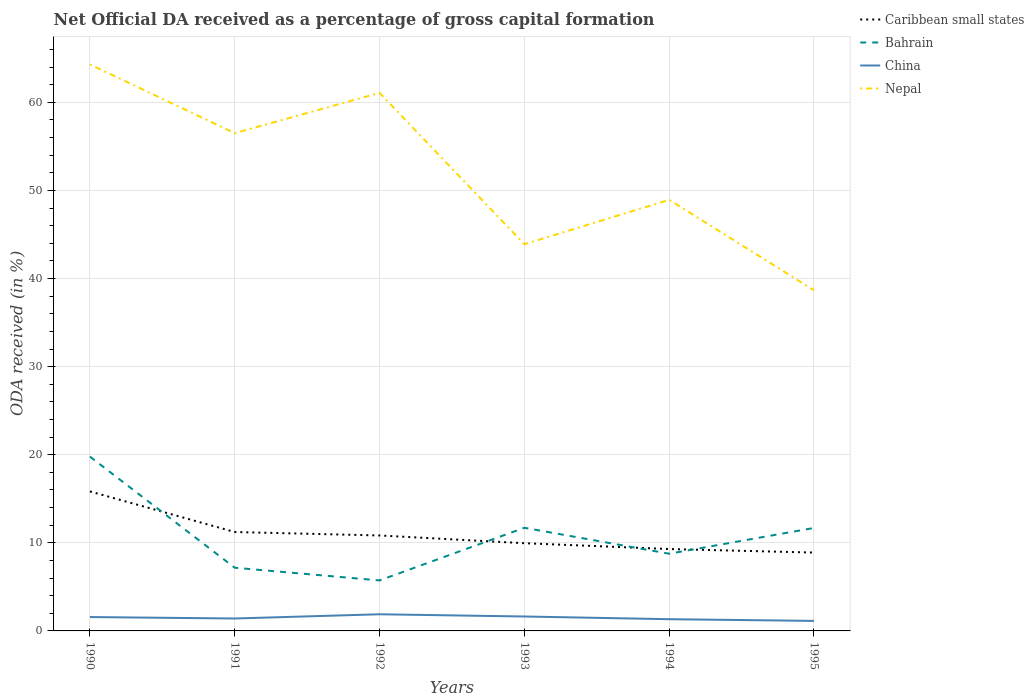How many different coloured lines are there?
Make the answer very short. 4. Is the number of lines equal to the number of legend labels?
Provide a short and direct response. Yes. Across all years, what is the maximum net ODA received in China?
Ensure brevity in your answer.  1.14. In which year was the net ODA received in Nepal maximum?
Provide a short and direct response. 1995. What is the total net ODA received in Bahrain in the graph?
Your response must be concise. 1.44. What is the difference between the highest and the second highest net ODA received in Nepal?
Your response must be concise. 25.64. What is the difference between the highest and the lowest net ODA received in China?
Keep it short and to the point. 3. How many years are there in the graph?
Give a very brief answer. 6. Are the values on the major ticks of Y-axis written in scientific E-notation?
Your response must be concise. No. Does the graph contain any zero values?
Your response must be concise. No. Does the graph contain grids?
Keep it short and to the point. Yes. Where does the legend appear in the graph?
Keep it short and to the point. Top right. What is the title of the graph?
Offer a very short reply. Net Official DA received as a percentage of gross capital formation. Does "Lithuania" appear as one of the legend labels in the graph?
Provide a succinct answer. No. What is the label or title of the Y-axis?
Offer a terse response. ODA received (in %). What is the ODA received (in %) in Caribbean small states in 1990?
Your response must be concise. 15.84. What is the ODA received (in %) in Bahrain in 1990?
Provide a short and direct response. 19.79. What is the ODA received (in %) in China in 1990?
Keep it short and to the point. 1.58. What is the ODA received (in %) in Nepal in 1990?
Give a very brief answer. 64.31. What is the ODA received (in %) in Caribbean small states in 1991?
Your response must be concise. 11.23. What is the ODA received (in %) in Bahrain in 1991?
Ensure brevity in your answer.  7.17. What is the ODA received (in %) of China in 1991?
Ensure brevity in your answer.  1.41. What is the ODA received (in %) in Nepal in 1991?
Give a very brief answer. 56.5. What is the ODA received (in %) in Caribbean small states in 1992?
Ensure brevity in your answer.  10.84. What is the ODA received (in %) in Bahrain in 1992?
Ensure brevity in your answer.  5.73. What is the ODA received (in %) in China in 1992?
Provide a succinct answer. 1.89. What is the ODA received (in %) in Nepal in 1992?
Keep it short and to the point. 61.08. What is the ODA received (in %) of Caribbean small states in 1993?
Your answer should be very brief. 9.96. What is the ODA received (in %) in Bahrain in 1993?
Ensure brevity in your answer.  11.71. What is the ODA received (in %) in China in 1993?
Provide a short and direct response. 1.64. What is the ODA received (in %) in Nepal in 1993?
Ensure brevity in your answer.  43.9. What is the ODA received (in %) of Caribbean small states in 1994?
Provide a succinct answer. 9.3. What is the ODA received (in %) in Bahrain in 1994?
Your answer should be very brief. 8.76. What is the ODA received (in %) in China in 1994?
Make the answer very short. 1.33. What is the ODA received (in %) of Nepal in 1994?
Keep it short and to the point. 48.94. What is the ODA received (in %) of Caribbean small states in 1995?
Give a very brief answer. 8.89. What is the ODA received (in %) in Bahrain in 1995?
Provide a succinct answer. 11.69. What is the ODA received (in %) of China in 1995?
Make the answer very short. 1.14. What is the ODA received (in %) in Nepal in 1995?
Your answer should be compact. 38.66. Across all years, what is the maximum ODA received (in %) in Caribbean small states?
Your response must be concise. 15.84. Across all years, what is the maximum ODA received (in %) of Bahrain?
Your answer should be compact. 19.79. Across all years, what is the maximum ODA received (in %) of China?
Provide a short and direct response. 1.89. Across all years, what is the maximum ODA received (in %) in Nepal?
Offer a very short reply. 64.31. Across all years, what is the minimum ODA received (in %) of Caribbean small states?
Provide a short and direct response. 8.89. Across all years, what is the minimum ODA received (in %) of Bahrain?
Your response must be concise. 5.73. Across all years, what is the minimum ODA received (in %) of China?
Your answer should be compact. 1.14. Across all years, what is the minimum ODA received (in %) of Nepal?
Give a very brief answer. 38.66. What is the total ODA received (in %) of Caribbean small states in the graph?
Make the answer very short. 66.05. What is the total ODA received (in %) in Bahrain in the graph?
Give a very brief answer. 64.85. What is the total ODA received (in %) in China in the graph?
Keep it short and to the point. 8.98. What is the total ODA received (in %) in Nepal in the graph?
Provide a short and direct response. 313.39. What is the difference between the ODA received (in %) of Caribbean small states in 1990 and that in 1991?
Keep it short and to the point. 4.61. What is the difference between the ODA received (in %) in Bahrain in 1990 and that in 1991?
Keep it short and to the point. 12.61. What is the difference between the ODA received (in %) in China in 1990 and that in 1991?
Give a very brief answer. 0.17. What is the difference between the ODA received (in %) in Nepal in 1990 and that in 1991?
Make the answer very short. 7.81. What is the difference between the ODA received (in %) of Caribbean small states in 1990 and that in 1992?
Offer a very short reply. 5. What is the difference between the ODA received (in %) in Bahrain in 1990 and that in 1992?
Give a very brief answer. 14.05. What is the difference between the ODA received (in %) of China in 1990 and that in 1992?
Your answer should be very brief. -0.32. What is the difference between the ODA received (in %) in Nepal in 1990 and that in 1992?
Your answer should be compact. 3.23. What is the difference between the ODA received (in %) of Caribbean small states in 1990 and that in 1993?
Keep it short and to the point. 5.88. What is the difference between the ODA received (in %) in Bahrain in 1990 and that in 1993?
Offer a terse response. 8.08. What is the difference between the ODA received (in %) in China in 1990 and that in 1993?
Give a very brief answer. -0.06. What is the difference between the ODA received (in %) of Nepal in 1990 and that in 1993?
Your answer should be compact. 20.41. What is the difference between the ODA received (in %) in Caribbean small states in 1990 and that in 1994?
Ensure brevity in your answer.  6.54. What is the difference between the ODA received (in %) in Bahrain in 1990 and that in 1994?
Your response must be concise. 11.02. What is the difference between the ODA received (in %) of China in 1990 and that in 1994?
Your response must be concise. 0.25. What is the difference between the ODA received (in %) of Nepal in 1990 and that in 1994?
Make the answer very short. 15.37. What is the difference between the ODA received (in %) in Caribbean small states in 1990 and that in 1995?
Your response must be concise. 6.94. What is the difference between the ODA received (in %) in Bahrain in 1990 and that in 1995?
Make the answer very short. 8.1. What is the difference between the ODA received (in %) of China in 1990 and that in 1995?
Your response must be concise. 0.44. What is the difference between the ODA received (in %) of Nepal in 1990 and that in 1995?
Keep it short and to the point. 25.64. What is the difference between the ODA received (in %) in Caribbean small states in 1991 and that in 1992?
Offer a terse response. 0.39. What is the difference between the ODA received (in %) of Bahrain in 1991 and that in 1992?
Ensure brevity in your answer.  1.44. What is the difference between the ODA received (in %) in China in 1991 and that in 1992?
Ensure brevity in your answer.  -0.48. What is the difference between the ODA received (in %) in Nepal in 1991 and that in 1992?
Make the answer very short. -4.57. What is the difference between the ODA received (in %) in Caribbean small states in 1991 and that in 1993?
Provide a succinct answer. 1.27. What is the difference between the ODA received (in %) in Bahrain in 1991 and that in 1993?
Your answer should be compact. -4.53. What is the difference between the ODA received (in %) in China in 1991 and that in 1993?
Keep it short and to the point. -0.23. What is the difference between the ODA received (in %) of Nepal in 1991 and that in 1993?
Keep it short and to the point. 12.6. What is the difference between the ODA received (in %) of Caribbean small states in 1991 and that in 1994?
Provide a short and direct response. 1.93. What is the difference between the ODA received (in %) of Bahrain in 1991 and that in 1994?
Make the answer very short. -1.59. What is the difference between the ODA received (in %) of China in 1991 and that in 1994?
Keep it short and to the point. 0.08. What is the difference between the ODA received (in %) in Nepal in 1991 and that in 1994?
Offer a terse response. 7.57. What is the difference between the ODA received (in %) of Caribbean small states in 1991 and that in 1995?
Keep it short and to the point. 2.33. What is the difference between the ODA received (in %) of Bahrain in 1991 and that in 1995?
Provide a short and direct response. -4.51. What is the difference between the ODA received (in %) of China in 1991 and that in 1995?
Ensure brevity in your answer.  0.27. What is the difference between the ODA received (in %) in Nepal in 1991 and that in 1995?
Give a very brief answer. 17.84. What is the difference between the ODA received (in %) of Caribbean small states in 1992 and that in 1993?
Make the answer very short. 0.88. What is the difference between the ODA received (in %) in Bahrain in 1992 and that in 1993?
Your answer should be compact. -5.97. What is the difference between the ODA received (in %) in China in 1992 and that in 1993?
Keep it short and to the point. 0.25. What is the difference between the ODA received (in %) in Nepal in 1992 and that in 1993?
Provide a succinct answer. 17.18. What is the difference between the ODA received (in %) of Caribbean small states in 1992 and that in 1994?
Make the answer very short. 1.54. What is the difference between the ODA received (in %) in Bahrain in 1992 and that in 1994?
Ensure brevity in your answer.  -3.03. What is the difference between the ODA received (in %) of China in 1992 and that in 1994?
Provide a succinct answer. 0.56. What is the difference between the ODA received (in %) in Nepal in 1992 and that in 1994?
Ensure brevity in your answer.  12.14. What is the difference between the ODA received (in %) in Caribbean small states in 1992 and that in 1995?
Your response must be concise. 1.94. What is the difference between the ODA received (in %) in Bahrain in 1992 and that in 1995?
Your response must be concise. -5.96. What is the difference between the ODA received (in %) in China in 1992 and that in 1995?
Ensure brevity in your answer.  0.75. What is the difference between the ODA received (in %) in Nepal in 1992 and that in 1995?
Your response must be concise. 22.41. What is the difference between the ODA received (in %) of Caribbean small states in 1993 and that in 1994?
Give a very brief answer. 0.66. What is the difference between the ODA received (in %) in Bahrain in 1993 and that in 1994?
Make the answer very short. 2.94. What is the difference between the ODA received (in %) in China in 1993 and that in 1994?
Ensure brevity in your answer.  0.31. What is the difference between the ODA received (in %) in Nepal in 1993 and that in 1994?
Your response must be concise. -5.04. What is the difference between the ODA received (in %) in Caribbean small states in 1993 and that in 1995?
Keep it short and to the point. 1.06. What is the difference between the ODA received (in %) of Bahrain in 1993 and that in 1995?
Provide a short and direct response. 0.02. What is the difference between the ODA received (in %) in China in 1993 and that in 1995?
Your answer should be compact. 0.5. What is the difference between the ODA received (in %) in Nepal in 1993 and that in 1995?
Your answer should be compact. 5.24. What is the difference between the ODA received (in %) of Caribbean small states in 1994 and that in 1995?
Your response must be concise. 0.4. What is the difference between the ODA received (in %) in Bahrain in 1994 and that in 1995?
Your answer should be very brief. -2.92. What is the difference between the ODA received (in %) in China in 1994 and that in 1995?
Provide a succinct answer. 0.19. What is the difference between the ODA received (in %) in Nepal in 1994 and that in 1995?
Give a very brief answer. 10.27. What is the difference between the ODA received (in %) in Caribbean small states in 1990 and the ODA received (in %) in Bahrain in 1991?
Ensure brevity in your answer.  8.66. What is the difference between the ODA received (in %) in Caribbean small states in 1990 and the ODA received (in %) in China in 1991?
Offer a terse response. 14.43. What is the difference between the ODA received (in %) in Caribbean small states in 1990 and the ODA received (in %) in Nepal in 1991?
Provide a short and direct response. -40.67. What is the difference between the ODA received (in %) of Bahrain in 1990 and the ODA received (in %) of China in 1991?
Your response must be concise. 18.38. What is the difference between the ODA received (in %) of Bahrain in 1990 and the ODA received (in %) of Nepal in 1991?
Your answer should be very brief. -36.72. What is the difference between the ODA received (in %) in China in 1990 and the ODA received (in %) in Nepal in 1991?
Offer a terse response. -54.93. What is the difference between the ODA received (in %) in Caribbean small states in 1990 and the ODA received (in %) in Bahrain in 1992?
Give a very brief answer. 10.1. What is the difference between the ODA received (in %) of Caribbean small states in 1990 and the ODA received (in %) of China in 1992?
Provide a succinct answer. 13.95. What is the difference between the ODA received (in %) in Caribbean small states in 1990 and the ODA received (in %) in Nepal in 1992?
Give a very brief answer. -45.24. What is the difference between the ODA received (in %) of Bahrain in 1990 and the ODA received (in %) of China in 1992?
Make the answer very short. 17.9. What is the difference between the ODA received (in %) of Bahrain in 1990 and the ODA received (in %) of Nepal in 1992?
Give a very brief answer. -41.29. What is the difference between the ODA received (in %) of China in 1990 and the ODA received (in %) of Nepal in 1992?
Provide a succinct answer. -59.5. What is the difference between the ODA received (in %) in Caribbean small states in 1990 and the ODA received (in %) in Bahrain in 1993?
Your answer should be very brief. 4.13. What is the difference between the ODA received (in %) in Caribbean small states in 1990 and the ODA received (in %) in China in 1993?
Provide a short and direct response. 14.2. What is the difference between the ODA received (in %) in Caribbean small states in 1990 and the ODA received (in %) in Nepal in 1993?
Keep it short and to the point. -28.06. What is the difference between the ODA received (in %) in Bahrain in 1990 and the ODA received (in %) in China in 1993?
Provide a succinct answer. 18.15. What is the difference between the ODA received (in %) in Bahrain in 1990 and the ODA received (in %) in Nepal in 1993?
Give a very brief answer. -24.11. What is the difference between the ODA received (in %) in China in 1990 and the ODA received (in %) in Nepal in 1993?
Offer a very short reply. -42.32. What is the difference between the ODA received (in %) of Caribbean small states in 1990 and the ODA received (in %) of Bahrain in 1994?
Provide a succinct answer. 7.07. What is the difference between the ODA received (in %) of Caribbean small states in 1990 and the ODA received (in %) of China in 1994?
Your answer should be compact. 14.51. What is the difference between the ODA received (in %) of Caribbean small states in 1990 and the ODA received (in %) of Nepal in 1994?
Keep it short and to the point. -33.1. What is the difference between the ODA received (in %) in Bahrain in 1990 and the ODA received (in %) in China in 1994?
Make the answer very short. 18.46. What is the difference between the ODA received (in %) in Bahrain in 1990 and the ODA received (in %) in Nepal in 1994?
Provide a short and direct response. -29.15. What is the difference between the ODA received (in %) in China in 1990 and the ODA received (in %) in Nepal in 1994?
Your answer should be very brief. -47.36. What is the difference between the ODA received (in %) in Caribbean small states in 1990 and the ODA received (in %) in Bahrain in 1995?
Your answer should be very brief. 4.15. What is the difference between the ODA received (in %) in Caribbean small states in 1990 and the ODA received (in %) in China in 1995?
Make the answer very short. 14.7. What is the difference between the ODA received (in %) of Caribbean small states in 1990 and the ODA received (in %) of Nepal in 1995?
Keep it short and to the point. -22.83. What is the difference between the ODA received (in %) in Bahrain in 1990 and the ODA received (in %) in China in 1995?
Provide a short and direct response. 18.65. What is the difference between the ODA received (in %) of Bahrain in 1990 and the ODA received (in %) of Nepal in 1995?
Your response must be concise. -18.88. What is the difference between the ODA received (in %) of China in 1990 and the ODA received (in %) of Nepal in 1995?
Give a very brief answer. -37.09. What is the difference between the ODA received (in %) in Caribbean small states in 1991 and the ODA received (in %) in Bahrain in 1992?
Keep it short and to the point. 5.49. What is the difference between the ODA received (in %) in Caribbean small states in 1991 and the ODA received (in %) in China in 1992?
Your answer should be compact. 9.34. What is the difference between the ODA received (in %) in Caribbean small states in 1991 and the ODA received (in %) in Nepal in 1992?
Offer a terse response. -49.85. What is the difference between the ODA received (in %) of Bahrain in 1991 and the ODA received (in %) of China in 1992?
Offer a very short reply. 5.28. What is the difference between the ODA received (in %) in Bahrain in 1991 and the ODA received (in %) in Nepal in 1992?
Your answer should be compact. -53.9. What is the difference between the ODA received (in %) in China in 1991 and the ODA received (in %) in Nepal in 1992?
Your response must be concise. -59.67. What is the difference between the ODA received (in %) of Caribbean small states in 1991 and the ODA received (in %) of Bahrain in 1993?
Keep it short and to the point. -0.48. What is the difference between the ODA received (in %) of Caribbean small states in 1991 and the ODA received (in %) of China in 1993?
Ensure brevity in your answer.  9.59. What is the difference between the ODA received (in %) in Caribbean small states in 1991 and the ODA received (in %) in Nepal in 1993?
Provide a succinct answer. -32.67. What is the difference between the ODA received (in %) of Bahrain in 1991 and the ODA received (in %) of China in 1993?
Your answer should be very brief. 5.54. What is the difference between the ODA received (in %) in Bahrain in 1991 and the ODA received (in %) in Nepal in 1993?
Give a very brief answer. -36.73. What is the difference between the ODA received (in %) in China in 1991 and the ODA received (in %) in Nepal in 1993?
Ensure brevity in your answer.  -42.49. What is the difference between the ODA received (in %) of Caribbean small states in 1991 and the ODA received (in %) of Bahrain in 1994?
Offer a very short reply. 2.46. What is the difference between the ODA received (in %) of Caribbean small states in 1991 and the ODA received (in %) of China in 1994?
Make the answer very short. 9.9. What is the difference between the ODA received (in %) in Caribbean small states in 1991 and the ODA received (in %) in Nepal in 1994?
Provide a succinct answer. -37.71. What is the difference between the ODA received (in %) in Bahrain in 1991 and the ODA received (in %) in China in 1994?
Keep it short and to the point. 5.84. What is the difference between the ODA received (in %) of Bahrain in 1991 and the ODA received (in %) of Nepal in 1994?
Your answer should be compact. -41.76. What is the difference between the ODA received (in %) of China in 1991 and the ODA received (in %) of Nepal in 1994?
Make the answer very short. -47.53. What is the difference between the ODA received (in %) in Caribbean small states in 1991 and the ODA received (in %) in Bahrain in 1995?
Ensure brevity in your answer.  -0.46. What is the difference between the ODA received (in %) of Caribbean small states in 1991 and the ODA received (in %) of China in 1995?
Ensure brevity in your answer.  10.09. What is the difference between the ODA received (in %) in Caribbean small states in 1991 and the ODA received (in %) in Nepal in 1995?
Ensure brevity in your answer.  -27.44. What is the difference between the ODA received (in %) in Bahrain in 1991 and the ODA received (in %) in China in 1995?
Provide a short and direct response. 6.04. What is the difference between the ODA received (in %) of Bahrain in 1991 and the ODA received (in %) of Nepal in 1995?
Offer a terse response. -31.49. What is the difference between the ODA received (in %) of China in 1991 and the ODA received (in %) of Nepal in 1995?
Offer a very short reply. -37.25. What is the difference between the ODA received (in %) of Caribbean small states in 1992 and the ODA received (in %) of Bahrain in 1993?
Your answer should be very brief. -0.87. What is the difference between the ODA received (in %) in Caribbean small states in 1992 and the ODA received (in %) in China in 1993?
Make the answer very short. 9.2. What is the difference between the ODA received (in %) of Caribbean small states in 1992 and the ODA received (in %) of Nepal in 1993?
Your answer should be very brief. -33.06. What is the difference between the ODA received (in %) in Bahrain in 1992 and the ODA received (in %) in China in 1993?
Ensure brevity in your answer.  4.1. What is the difference between the ODA received (in %) of Bahrain in 1992 and the ODA received (in %) of Nepal in 1993?
Provide a succinct answer. -38.17. What is the difference between the ODA received (in %) in China in 1992 and the ODA received (in %) in Nepal in 1993?
Ensure brevity in your answer.  -42.01. What is the difference between the ODA received (in %) of Caribbean small states in 1992 and the ODA received (in %) of Bahrain in 1994?
Provide a short and direct response. 2.07. What is the difference between the ODA received (in %) of Caribbean small states in 1992 and the ODA received (in %) of China in 1994?
Offer a very short reply. 9.51. What is the difference between the ODA received (in %) of Caribbean small states in 1992 and the ODA received (in %) of Nepal in 1994?
Give a very brief answer. -38.1. What is the difference between the ODA received (in %) of Bahrain in 1992 and the ODA received (in %) of China in 1994?
Give a very brief answer. 4.4. What is the difference between the ODA received (in %) of Bahrain in 1992 and the ODA received (in %) of Nepal in 1994?
Your answer should be very brief. -43.2. What is the difference between the ODA received (in %) in China in 1992 and the ODA received (in %) in Nepal in 1994?
Offer a terse response. -47.05. What is the difference between the ODA received (in %) of Caribbean small states in 1992 and the ODA received (in %) of Bahrain in 1995?
Ensure brevity in your answer.  -0.85. What is the difference between the ODA received (in %) of Caribbean small states in 1992 and the ODA received (in %) of China in 1995?
Your response must be concise. 9.7. What is the difference between the ODA received (in %) of Caribbean small states in 1992 and the ODA received (in %) of Nepal in 1995?
Keep it short and to the point. -27.83. What is the difference between the ODA received (in %) in Bahrain in 1992 and the ODA received (in %) in China in 1995?
Your answer should be very brief. 4.59. What is the difference between the ODA received (in %) in Bahrain in 1992 and the ODA received (in %) in Nepal in 1995?
Give a very brief answer. -32.93. What is the difference between the ODA received (in %) of China in 1992 and the ODA received (in %) of Nepal in 1995?
Keep it short and to the point. -36.77. What is the difference between the ODA received (in %) in Caribbean small states in 1993 and the ODA received (in %) in Bahrain in 1994?
Your answer should be compact. 1.19. What is the difference between the ODA received (in %) of Caribbean small states in 1993 and the ODA received (in %) of China in 1994?
Make the answer very short. 8.63. What is the difference between the ODA received (in %) in Caribbean small states in 1993 and the ODA received (in %) in Nepal in 1994?
Your response must be concise. -38.98. What is the difference between the ODA received (in %) in Bahrain in 1993 and the ODA received (in %) in China in 1994?
Offer a terse response. 10.38. What is the difference between the ODA received (in %) in Bahrain in 1993 and the ODA received (in %) in Nepal in 1994?
Keep it short and to the point. -37.23. What is the difference between the ODA received (in %) of China in 1993 and the ODA received (in %) of Nepal in 1994?
Give a very brief answer. -47.3. What is the difference between the ODA received (in %) of Caribbean small states in 1993 and the ODA received (in %) of Bahrain in 1995?
Your response must be concise. -1.73. What is the difference between the ODA received (in %) of Caribbean small states in 1993 and the ODA received (in %) of China in 1995?
Offer a very short reply. 8.82. What is the difference between the ODA received (in %) in Caribbean small states in 1993 and the ODA received (in %) in Nepal in 1995?
Provide a succinct answer. -28.71. What is the difference between the ODA received (in %) in Bahrain in 1993 and the ODA received (in %) in China in 1995?
Provide a short and direct response. 10.57. What is the difference between the ODA received (in %) of Bahrain in 1993 and the ODA received (in %) of Nepal in 1995?
Make the answer very short. -26.96. What is the difference between the ODA received (in %) in China in 1993 and the ODA received (in %) in Nepal in 1995?
Your answer should be compact. -37.03. What is the difference between the ODA received (in %) of Caribbean small states in 1994 and the ODA received (in %) of Bahrain in 1995?
Give a very brief answer. -2.39. What is the difference between the ODA received (in %) of Caribbean small states in 1994 and the ODA received (in %) of China in 1995?
Your response must be concise. 8.16. What is the difference between the ODA received (in %) in Caribbean small states in 1994 and the ODA received (in %) in Nepal in 1995?
Provide a short and direct response. -29.37. What is the difference between the ODA received (in %) of Bahrain in 1994 and the ODA received (in %) of China in 1995?
Offer a terse response. 7.63. What is the difference between the ODA received (in %) of Bahrain in 1994 and the ODA received (in %) of Nepal in 1995?
Provide a succinct answer. -29.9. What is the difference between the ODA received (in %) of China in 1994 and the ODA received (in %) of Nepal in 1995?
Provide a succinct answer. -37.33. What is the average ODA received (in %) in Caribbean small states per year?
Keep it short and to the point. 11.01. What is the average ODA received (in %) of Bahrain per year?
Ensure brevity in your answer.  10.81. What is the average ODA received (in %) of China per year?
Your response must be concise. 1.5. What is the average ODA received (in %) in Nepal per year?
Provide a short and direct response. 52.23. In the year 1990, what is the difference between the ODA received (in %) of Caribbean small states and ODA received (in %) of Bahrain?
Your answer should be compact. -3.95. In the year 1990, what is the difference between the ODA received (in %) in Caribbean small states and ODA received (in %) in China?
Your response must be concise. 14.26. In the year 1990, what is the difference between the ODA received (in %) in Caribbean small states and ODA received (in %) in Nepal?
Provide a short and direct response. -48.47. In the year 1990, what is the difference between the ODA received (in %) of Bahrain and ODA received (in %) of China?
Offer a terse response. 18.21. In the year 1990, what is the difference between the ODA received (in %) of Bahrain and ODA received (in %) of Nepal?
Ensure brevity in your answer.  -44.52. In the year 1990, what is the difference between the ODA received (in %) of China and ODA received (in %) of Nepal?
Provide a short and direct response. -62.73. In the year 1991, what is the difference between the ODA received (in %) of Caribbean small states and ODA received (in %) of Bahrain?
Give a very brief answer. 4.05. In the year 1991, what is the difference between the ODA received (in %) of Caribbean small states and ODA received (in %) of China?
Give a very brief answer. 9.82. In the year 1991, what is the difference between the ODA received (in %) in Caribbean small states and ODA received (in %) in Nepal?
Your answer should be compact. -45.28. In the year 1991, what is the difference between the ODA received (in %) in Bahrain and ODA received (in %) in China?
Provide a succinct answer. 5.76. In the year 1991, what is the difference between the ODA received (in %) in Bahrain and ODA received (in %) in Nepal?
Provide a succinct answer. -49.33. In the year 1991, what is the difference between the ODA received (in %) of China and ODA received (in %) of Nepal?
Your answer should be compact. -55.09. In the year 1992, what is the difference between the ODA received (in %) of Caribbean small states and ODA received (in %) of Bahrain?
Offer a terse response. 5.1. In the year 1992, what is the difference between the ODA received (in %) in Caribbean small states and ODA received (in %) in China?
Make the answer very short. 8.95. In the year 1992, what is the difference between the ODA received (in %) of Caribbean small states and ODA received (in %) of Nepal?
Provide a succinct answer. -50.24. In the year 1992, what is the difference between the ODA received (in %) of Bahrain and ODA received (in %) of China?
Provide a succinct answer. 3.84. In the year 1992, what is the difference between the ODA received (in %) in Bahrain and ODA received (in %) in Nepal?
Your answer should be very brief. -55.35. In the year 1992, what is the difference between the ODA received (in %) in China and ODA received (in %) in Nepal?
Make the answer very short. -59.19. In the year 1993, what is the difference between the ODA received (in %) in Caribbean small states and ODA received (in %) in Bahrain?
Provide a succinct answer. -1.75. In the year 1993, what is the difference between the ODA received (in %) of Caribbean small states and ODA received (in %) of China?
Offer a very short reply. 8.32. In the year 1993, what is the difference between the ODA received (in %) in Caribbean small states and ODA received (in %) in Nepal?
Ensure brevity in your answer.  -33.94. In the year 1993, what is the difference between the ODA received (in %) of Bahrain and ODA received (in %) of China?
Offer a terse response. 10.07. In the year 1993, what is the difference between the ODA received (in %) of Bahrain and ODA received (in %) of Nepal?
Offer a terse response. -32.19. In the year 1993, what is the difference between the ODA received (in %) in China and ODA received (in %) in Nepal?
Offer a terse response. -42.26. In the year 1994, what is the difference between the ODA received (in %) of Caribbean small states and ODA received (in %) of Bahrain?
Make the answer very short. 0.53. In the year 1994, what is the difference between the ODA received (in %) of Caribbean small states and ODA received (in %) of China?
Make the answer very short. 7.97. In the year 1994, what is the difference between the ODA received (in %) in Caribbean small states and ODA received (in %) in Nepal?
Make the answer very short. -39.64. In the year 1994, what is the difference between the ODA received (in %) in Bahrain and ODA received (in %) in China?
Offer a terse response. 7.43. In the year 1994, what is the difference between the ODA received (in %) of Bahrain and ODA received (in %) of Nepal?
Ensure brevity in your answer.  -40.17. In the year 1994, what is the difference between the ODA received (in %) of China and ODA received (in %) of Nepal?
Your response must be concise. -47.61. In the year 1995, what is the difference between the ODA received (in %) in Caribbean small states and ODA received (in %) in Bahrain?
Provide a short and direct response. -2.79. In the year 1995, what is the difference between the ODA received (in %) in Caribbean small states and ODA received (in %) in China?
Give a very brief answer. 7.76. In the year 1995, what is the difference between the ODA received (in %) of Caribbean small states and ODA received (in %) of Nepal?
Your answer should be very brief. -29.77. In the year 1995, what is the difference between the ODA received (in %) in Bahrain and ODA received (in %) in China?
Ensure brevity in your answer.  10.55. In the year 1995, what is the difference between the ODA received (in %) of Bahrain and ODA received (in %) of Nepal?
Make the answer very short. -26.98. In the year 1995, what is the difference between the ODA received (in %) in China and ODA received (in %) in Nepal?
Offer a very short reply. -37.53. What is the ratio of the ODA received (in %) of Caribbean small states in 1990 to that in 1991?
Give a very brief answer. 1.41. What is the ratio of the ODA received (in %) of Bahrain in 1990 to that in 1991?
Your answer should be compact. 2.76. What is the ratio of the ODA received (in %) of China in 1990 to that in 1991?
Give a very brief answer. 1.12. What is the ratio of the ODA received (in %) in Nepal in 1990 to that in 1991?
Offer a terse response. 1.14. What is the ratio of the ODA received (in %) in Caribbean small states in 1990 to that in 1992?
Your answer should be very brief. 1.46. What is the ratio of the ODA received (in %) in Bahrain in 1990 to that in 1992?
Ensure brevity in your answer.  3.45. What is the ratio of the ODA received (in %) of Nepal in 1990 to that in 1992?
Offer a terse response. 1.05. What is the ratio of the ODA received (in %) in Caribbean small states in 1990 to that in 1993?
Your answer should be compact. 1.59. What is the ratio of the ODA received (in %) of Bahrain in 1990 to that in 1993?
Give a very brief answer. 1.69. What is the ratio of the ODA received (in %) in China in 1990 to that in 1993?
Give a very brief answer. 0.96. What is the ratio of the ODA received (in %) in Nepal in 1990 to that in 1993?
Your answer should be compact. 1.46. What is the ratio of the ODA received (in %) of Caribbean small states in 1990 to that in 1994?
Your answer should be compact. 1.7. What is the ratio of the ODA received (in %) of Bahrain in 1990 to that in 1994?
Offer a very short reply. 2.26. What is the ratio of the ODA received (in %) in China in 1990 to that in 1994?
Ensure brevity in your answer.  1.18. What is the ratio of the ODA received (in %) of Nepal in 1990 to that in 1994?
Offer a terse response. 1.31. What is the ratio of the ODA received (in %) of Caribbean small states in 1990 to that in 1995?
Offer a terse response. 1.78. What is the ratio of the ODA received (in %) in Bahrain in 1990 to that in 1995?
Offer a terse response. 1.69. What is the ratio of the ODA received (in %) of China in 1990 to that in 1995?
Give a very brief answer. 1.38. What is the ratio of the ODA received (in %) of Nepal in 1990 to that in 1995?
Keep it short and to the point. 1.66. What is the ratio of the ODA received (in %) in Caribbean small states in 1991 to that in 1992?
Your answer should be very brief. 1.04. What is the ratio of the ODA received (in %) of Bahrain in 1991 to that in 1992?
Offer a very short reply. 1.25. What is the ratio of the ODA received (in %) of China in 1991 to that in 1992?
Your response must be concise. 0.75. What is the ratio of the ODA received (in %) in Nepal in 1991 to that in 1992?
Keep it short and to the point. 0.93. What is the ratio of the ODA received (in %) in Caribbean small states in 1991 to that in 1993?
Make the answer very short. 1.13. What is the ratio of the ODA received (in %) of Bahrain in 1991 to that in 1993?
Offer a very short reply. 0.61. What is the ratio of the ODA received (in %) of China in 1991 to that in 1993?
Keep it short and to the point. 0.86. What is the ratio of the ODA received (in %) of Nepal in 1991 to that in 1993?
Offer a very short reply. 1.29. What is the ratio of the ODA received (in %) of Caribbean small states in 1991 to that in 1994?
Your answer should be very brief. 1.21. What is the ratio of the ODA received (in %) in Bahrain in 1991 to that in 1994?
Provide a succinct answer. 0.82. What is the ratio of the ODA received (in %) in China in 1991 to that in 1994?
Ensure brevity in your answer.  1.06. What is the ratio of the ODA received (in %) in Nepal in 1991 to that in 1994?
Your answer should be very brief. 1.15. What is the ratio of the ODA received (in %) of Caribbean small states in 1991 to that in 1995?
Give a very brief answer. 1.26. What is the ratio of the ODA received (in %) in Bahrain in 1991 to that in 1995?
Offer a terse response. 0.61. What is the ratio of the ODA received (in %) in China in 1991 to that in 1995?
Give a very brief answer. 1.24. What is the ratio of the ODA received (in %) of Nepal in 1991 to that in 1995?
Your response must be concise. 1.46. What is the ratio of the ODA received (in %) of Caribbean small states in 1992 to that in 1993?
Your response must be concise. 1.09. What is the ratio of the ODA received (in %) in Bahrain in 1992 to that in 1993?
Your answer should be very brief. 0.49. What is the ratio of the ODA received (in %) of China in 1992 to that in 1993?
Provide a succinct answer. 1.16. What is the ratio of the ODA received (in %) of Nepal in 1992 to that in 1993?
Your answer should be very brief. 1.39. What is the ratio of the ODA received (in %) in Caribbean small states in 1992 to that in 1994?
Give a very brief answer. 1.17. What is the ratio of the ODA received (in %) in Bahrain in 1992 to that in 1994?
Make the answer very short. 0.65. What is the ratio of the ODA received (in %) in China in 1992 to that in 1994?
Your answer should be compact. 1.42. What is the ratio of the ODA received (in %) of Nepal in 1992 to that in 1994?
Provide a short and direct response. 1.25. What is the ratio of the ODA received (in %) in Caribbean small states in 1992 to that in 1995?
Keep it short and to the point. 1.22. What is the ratio of the ODA received (in %) of Bahrain in 1992 to that in 1995?
Your answer should be compact. 0.49. What is the ratio of the ODA received (in %) of China in 1992 to that in 1995?
Your response must be concise. 1.66. What is the ratio of the ODA received (in %) in Nepal in 1992 to that in 1995?
Offer a terse response. 1.58. What is the ratio of the ODA received (in %) in Caribbean small states in 1993 to that in 1994?
Keep it short and to the point. 1.07. What is the ratio of the ODA received (in %) of Bahrain in 1993 to that in 1994?
Make the answer very short. 1.34. What is the ratio of the ODA received (in %) in China in 1993 to that in 1994?
Your answer should be compact. 1.23. What is the ratio of the ODA received (in %) of Nepal in 1993 to that in 1994?
Your answer should be very brief. 0.9. What is the ratio of the ODA received (in %) of Caribbean small states in 1993 to that in 1995?
Provide a short and direct response. 1.12. What is the ratio of the ODA received (in %) in Bahrain in 1993 to that in 1995?
Provide a short and direct response. 1. What is the ratio of the ODA received (in %) in China in 1993 to that in 1995?
Provide a short and direct response. 1.44. What is the ratio of the ODA received (in %) of Nepal in 1993 to that in 1995?
Keep it short and to the point. 1.14. What is the ratio of the ODA received (in %) in Caribbean small states in 1994 to that in 1995?
Provide a succinct answer. 1.05. What is the ratio of the ODA received (in %) in Bahrain in 1994 to that in 1995?
Give a very brief answer. 0.75. What is the ratio of the ODA received (in %) in China in 1994 to that in 1995?
Ensure brevity in your answer.  1.17. What is the ratio of the ODA received (in %) of Nepal in 1994 to that in 1995?
Ensure brevity in your answer.  1.27. What is the difference between the highest and the second highest ODA received (in %) of Caribbean small states?
Ensure brevity in your answer.  4.61. What is the difference between the highest and the second highest ODA received (in %) of Bahrain?
Ensure brevity in your answer.  8.08. What is the difference between the highest and the second highest ODA received (in %) in China?
Ensure brevity in your answer.  0.25. What is the difference between the highest and the second highest ODA received (in %) of Nepal?
Your answer should be very brief. 3.23. What is the difference between the highest and the lowest ODA received (in %) of Caribbean small states?
Make the answer very short. 6.94. What is the difference between the highest and the lowest ODA received (in %) of Bahrain?
Give a very brief answer. 14.05. What is the difference between the highest and the lowest ODA received (in %) in China?
Provide a succinct answer. 0.75. What is the difference between the highest and the lowest ODA received (in %) in Nepal?
Provide a succinct answer. 25.64. 